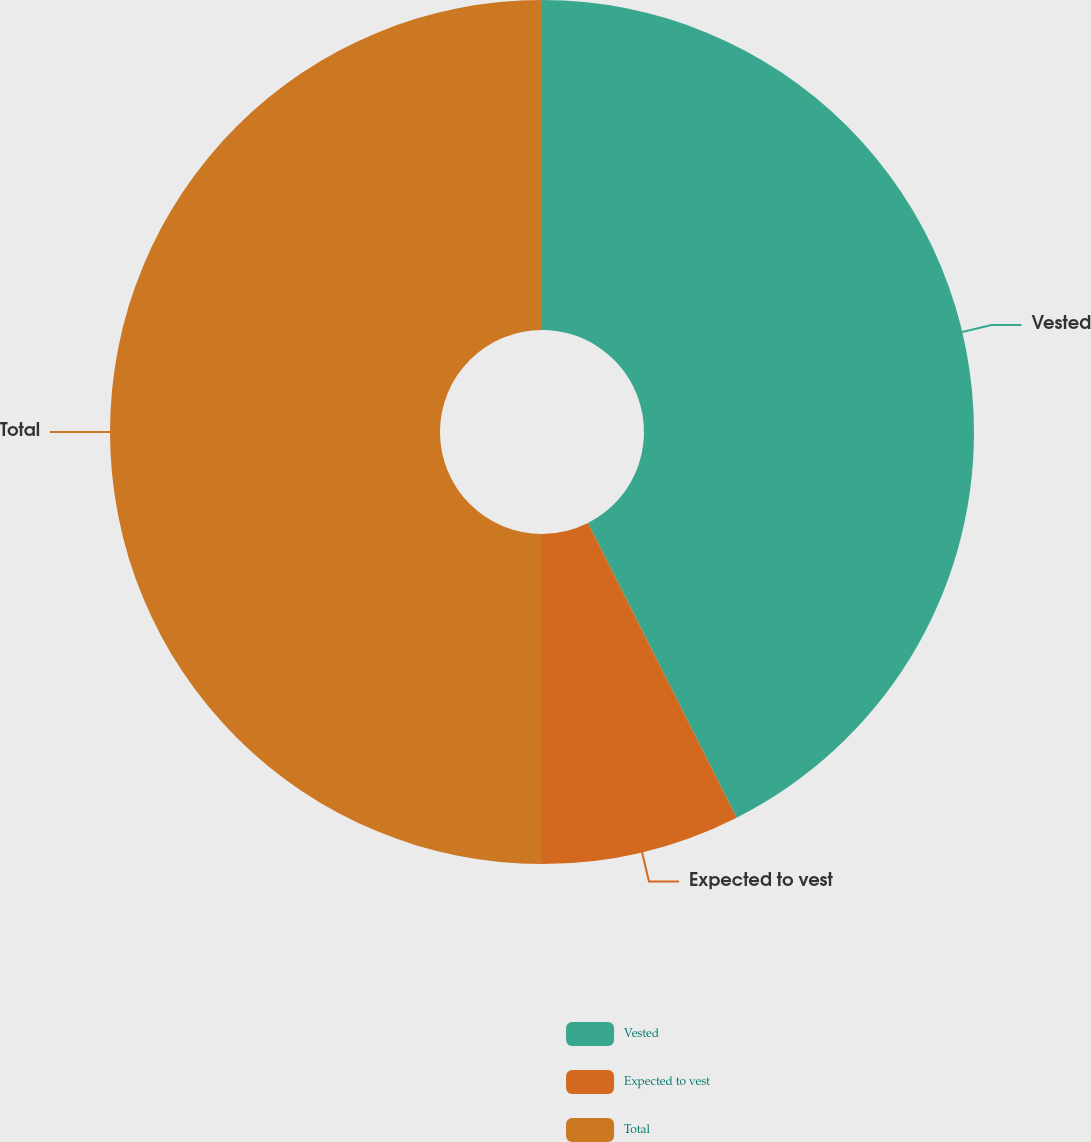<chart> <loc_0><loc_0><loc_500><loc_500><pie_chart><fcel>Vested<fcel>Expected to vest<fcel>Total<nl><fcel>42.56%<fcel>7.44%<fcel>50.0%<nl></chart> 